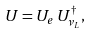<formula> <loc_0><loc_0><loc_500><loc_500>U = U _ { e } \, U _ { \nu _ { L } } ^ { \dag } ,</formula> 